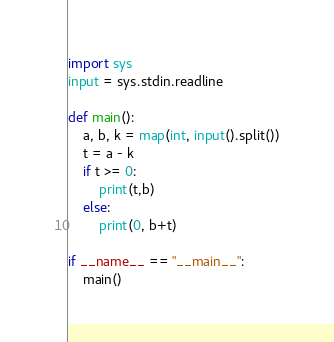Convert code to text. <code><loc_0><loc_0><loc_500><loc_500><_Python_>import sys
input = sys.stdin.readline

def main():
    a, b, k = map(int, input().split())
    t = a - k
    if t >= 0:
        print(t,b)
    else:
        print(0, b+t)

if __name__ == "__main__":
    main()</code> 